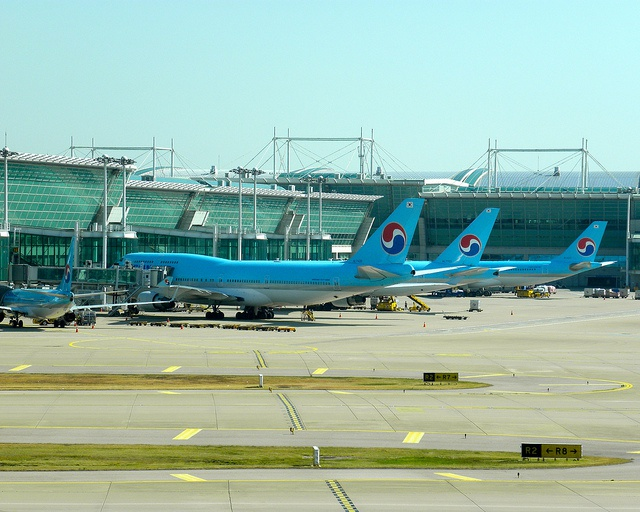Describe the objects in this image and their specific colors. I can see airplane in lightblue and teal tones, airplane in lightblue, teal, and gray tones, airplane in lightblue, teal, and gray tones, and airplane in lightblue, teal, gray, and black tones in this image. 